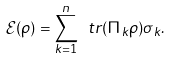<formula> <loc_0><loc_0><loc_500><loc_500>\mathcal { E } ( \rho ) = \sum _ { k = 1 } ^ { n } \ t r ( \Pi _ { k } \rho ) \sigma _ { k } .</formula> 